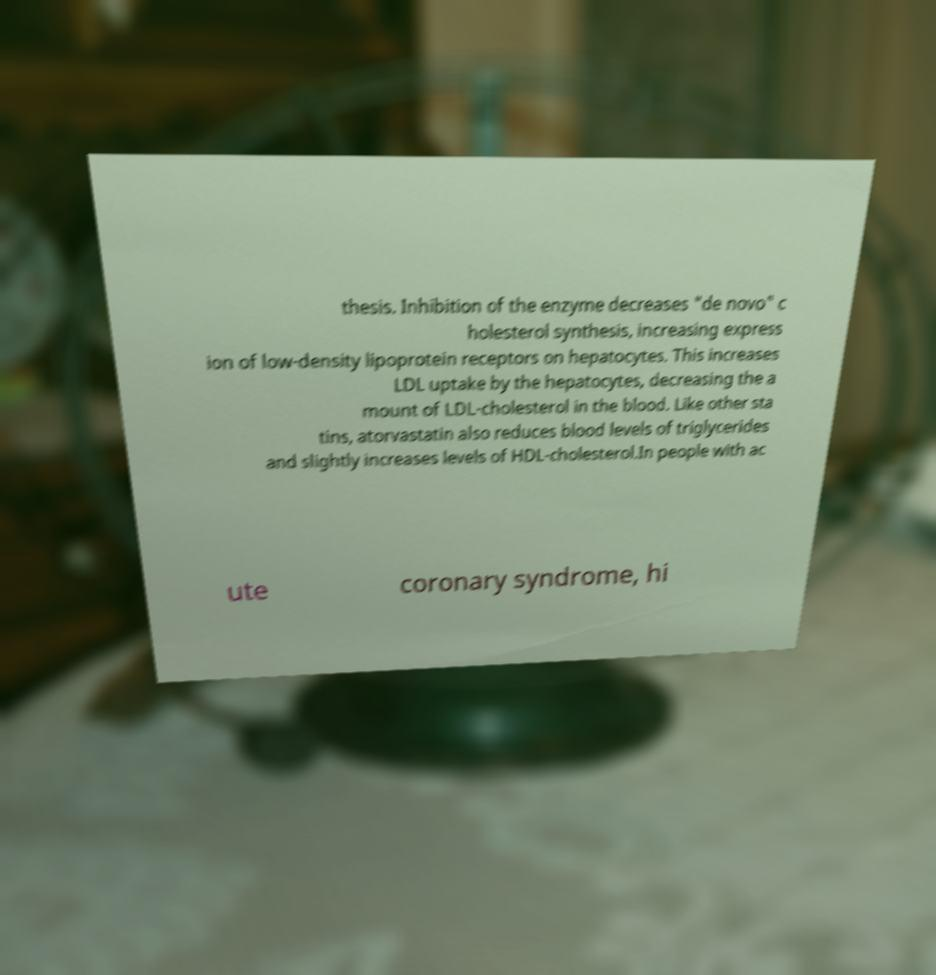There's text embedded in this image that I need extracted. Can you transcribe it verbatim? thesis. Inhibition of the enzyme decreases "de novo" c holesterol synthesis, increasing express ion of low-density lipoprotein receptors on hepatocytes. This increases LDL uptake by the hepatocytes, decreasing the a mount of LDL-cholesterol in the blood. Like other sta tins, atorvastatin also reduces blood levels of triglycerides and slightly increases levels of HDL-cholesterol.In people with ac ute coronary syndrome, hi 